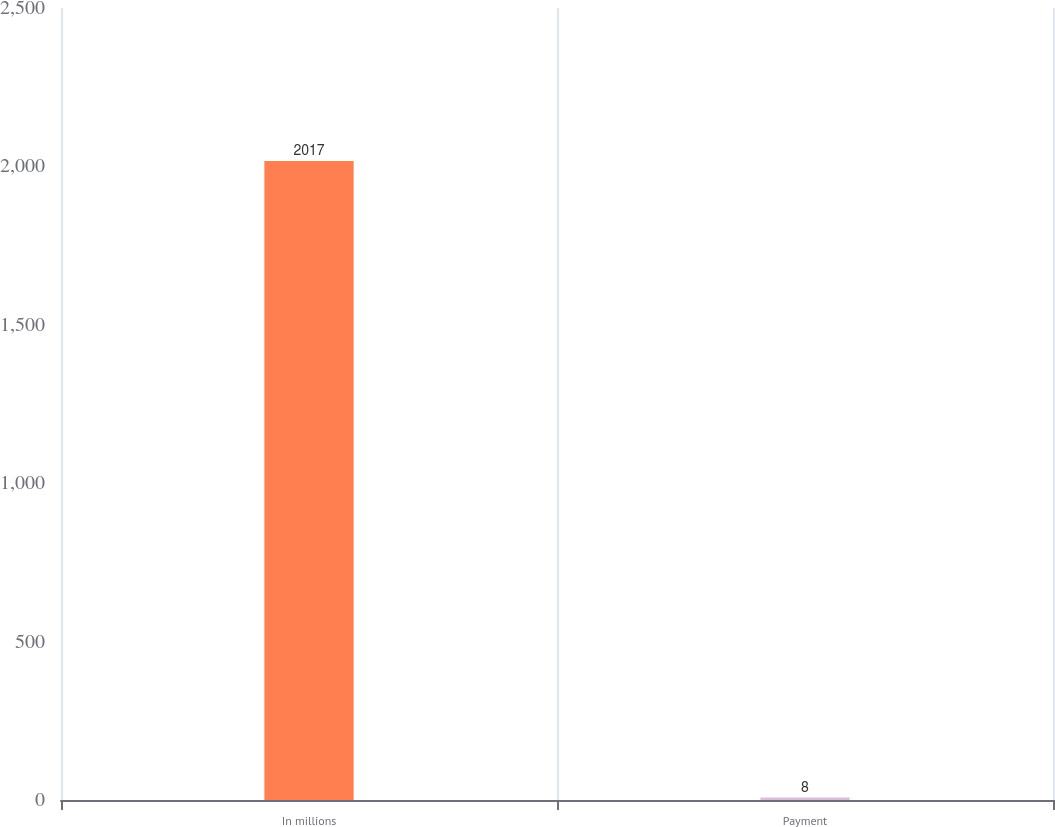<chart> <loc_0><loc_0><loc_500><loc_500><bar_chart><fcel>In millions<fcel>Payment<nl><fcel>2017<fcel>8<nl></chart> 